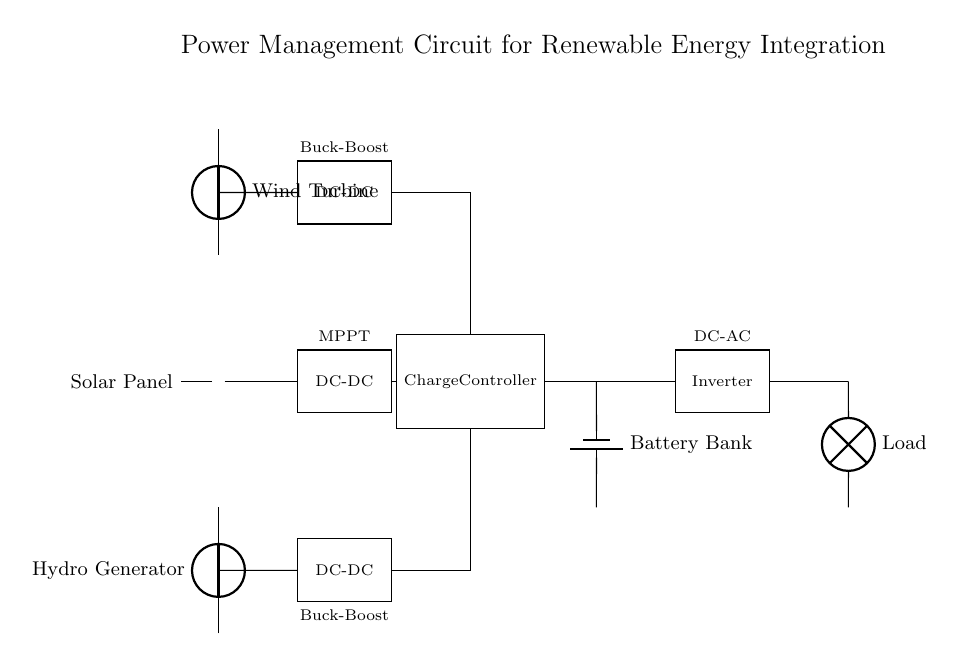What is the main type of circuit depicted? The circuit is a power management circuit integrating multiple renewable energy sources. It combines inputs from solar, wind, and hydro systems.
Answer: Power management circuit How many renewable energy sources are integrated? There are three sources visible: a solar panel, a wind turbine, and a hydro generator.
Answer: Three What component regulates the output voltage to the battery bank? The charge controller is responsible for regulating the voltage before it charges the battery bank.
Answer: Charge controller Which component converts DC to AC? The inverter is the component that converts direct current from the battery bank into alternating current for the load.
Answer: Inverter Why are DC-DC converters used in this circuit? DC-DC converters are used for voltage regulation and to adjust the output from the renewable sources to match the battery voltage, enhancing efficiency and performance.
Answer: To regulate voltage Describe the type of DC-DC converter used for solar input. The solar input utilizes a maximum power point tracking (MPPT) DC-DC converter to optimize the energy harvested from the solar panel.
Answer: MPPT What is the purpose of the battery bank in this circuit? The battery bank stores energy received from renewable sources, allowing for energy usage even when the sources are not actively producing power.
Answer: Energy storage 